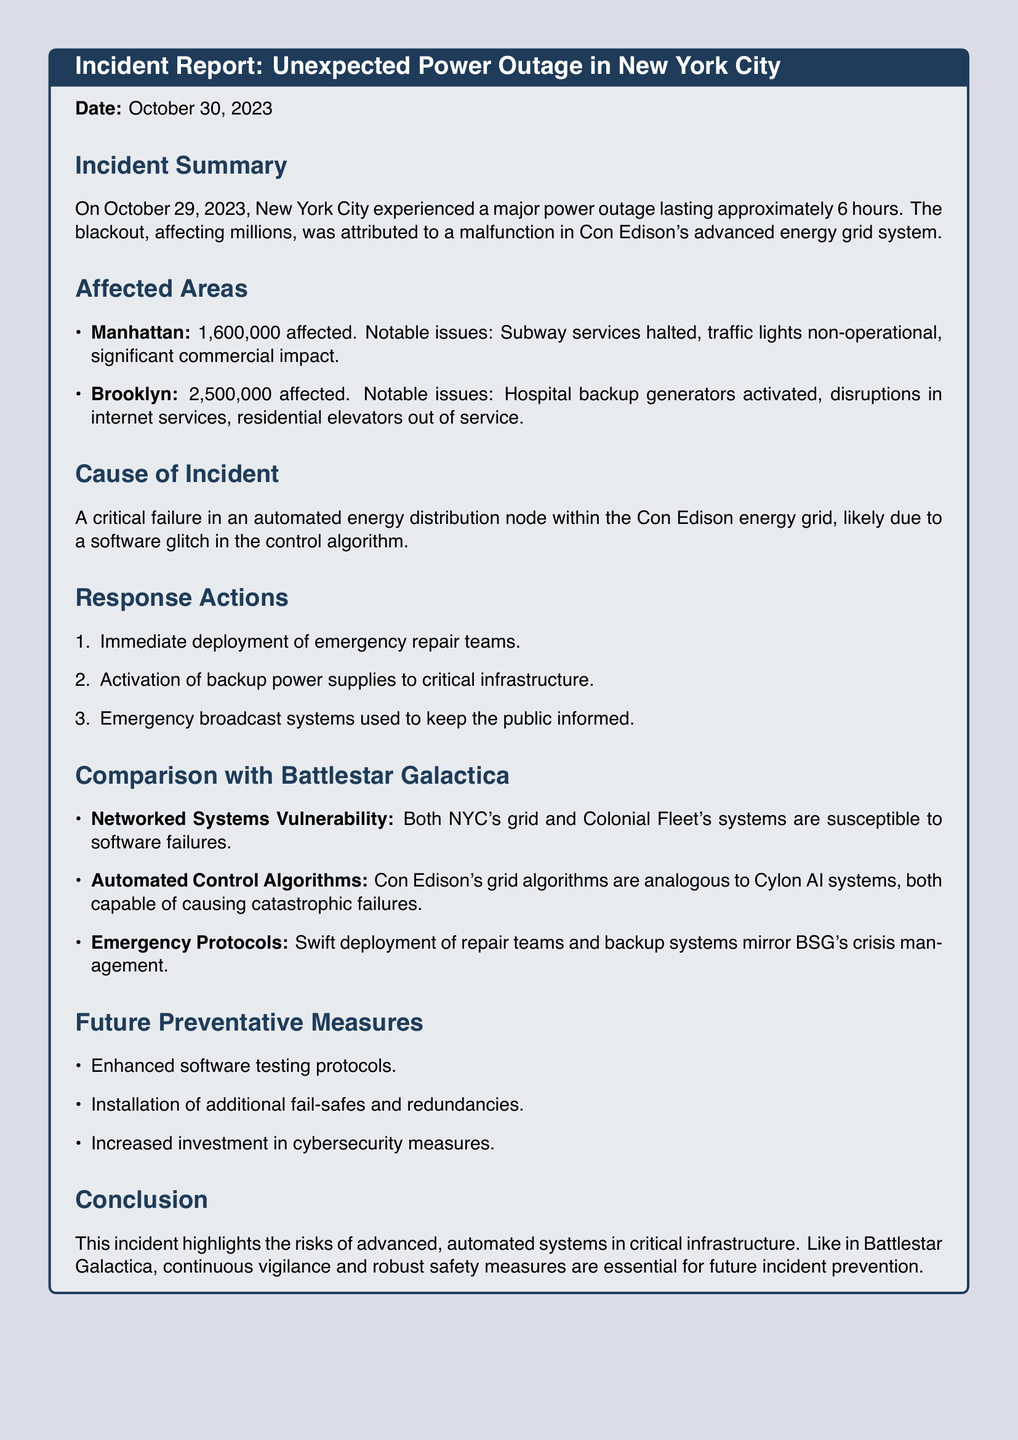what date did the power outage occur? The date of the power outage is mentioned in the incident summary section.
Answer: October 29, 2023 how many people were affected in Brooklyn? The number of affected people in Brooklyn is specified under the affected areas section.
Answer: 2,500,000 what caused the power outage? The cause of the outage is detailed in the cause of incident section of the report.
Answer: Software glitch what immediate action was taken by Con Edison? The response actions outline the immediate steps taken to remedy the situation.
Answer: Deployment of emergency repair teams what comparison is drawn between the energy grid malfunction and Battlestar Galactica? The document outlines similarities in vulnerabilities between the two systems.
Answer: Networked Systems Vulnerability what is one future preventative measure suggested in the report? Future preventive measures are listed to avoid similar incidents in the future.
Answer: Enhanced software testing protocols how long did the power outage last? The duration of the power outage is mentioned in the incident summary section.
Answer: 6 hours what was activated in hospitals during the outage? The notable issues in Brooklyn indicate what was activated during the power outage.
Answer: Backup generators 